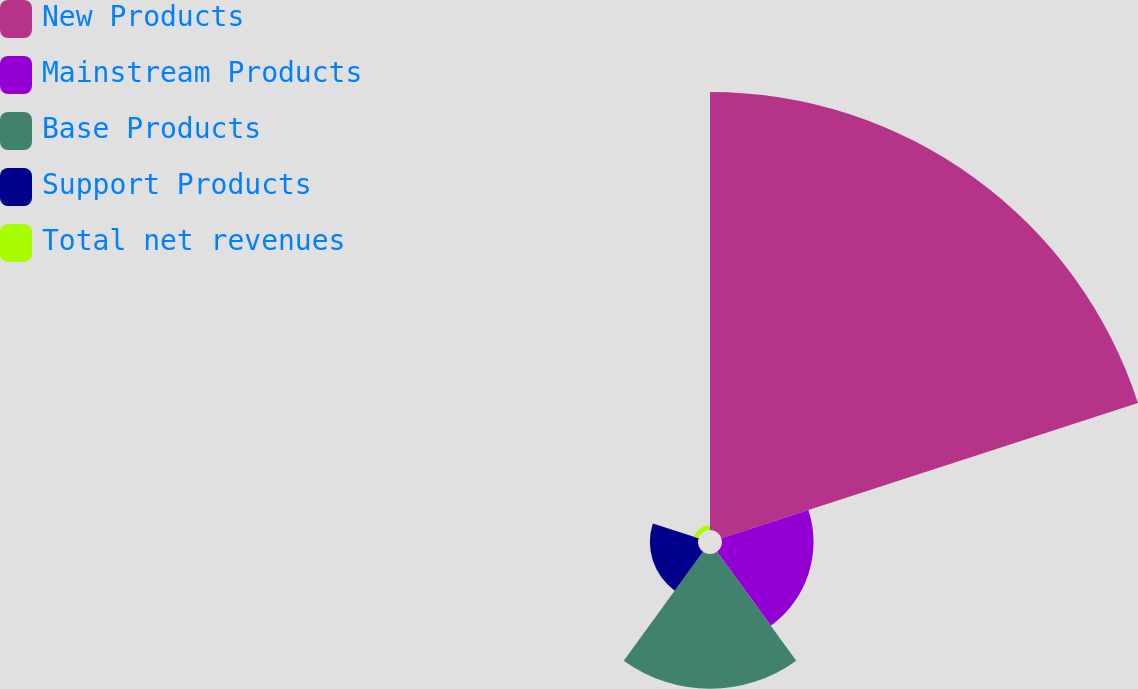Convert chart to OTSL. <chart><loc_0><loc_0><loc_500><loc_500><pie_chart><fcel>New Products<fcel>Mainstream Products<fcel>Base Products<fcel>Support Products<fcel>Total net revenues<nl><fcel>61.08%<fcel>12.76%<fcel>18.79%<fcel>6.71%<fcel>0.67%<nl></chart> 